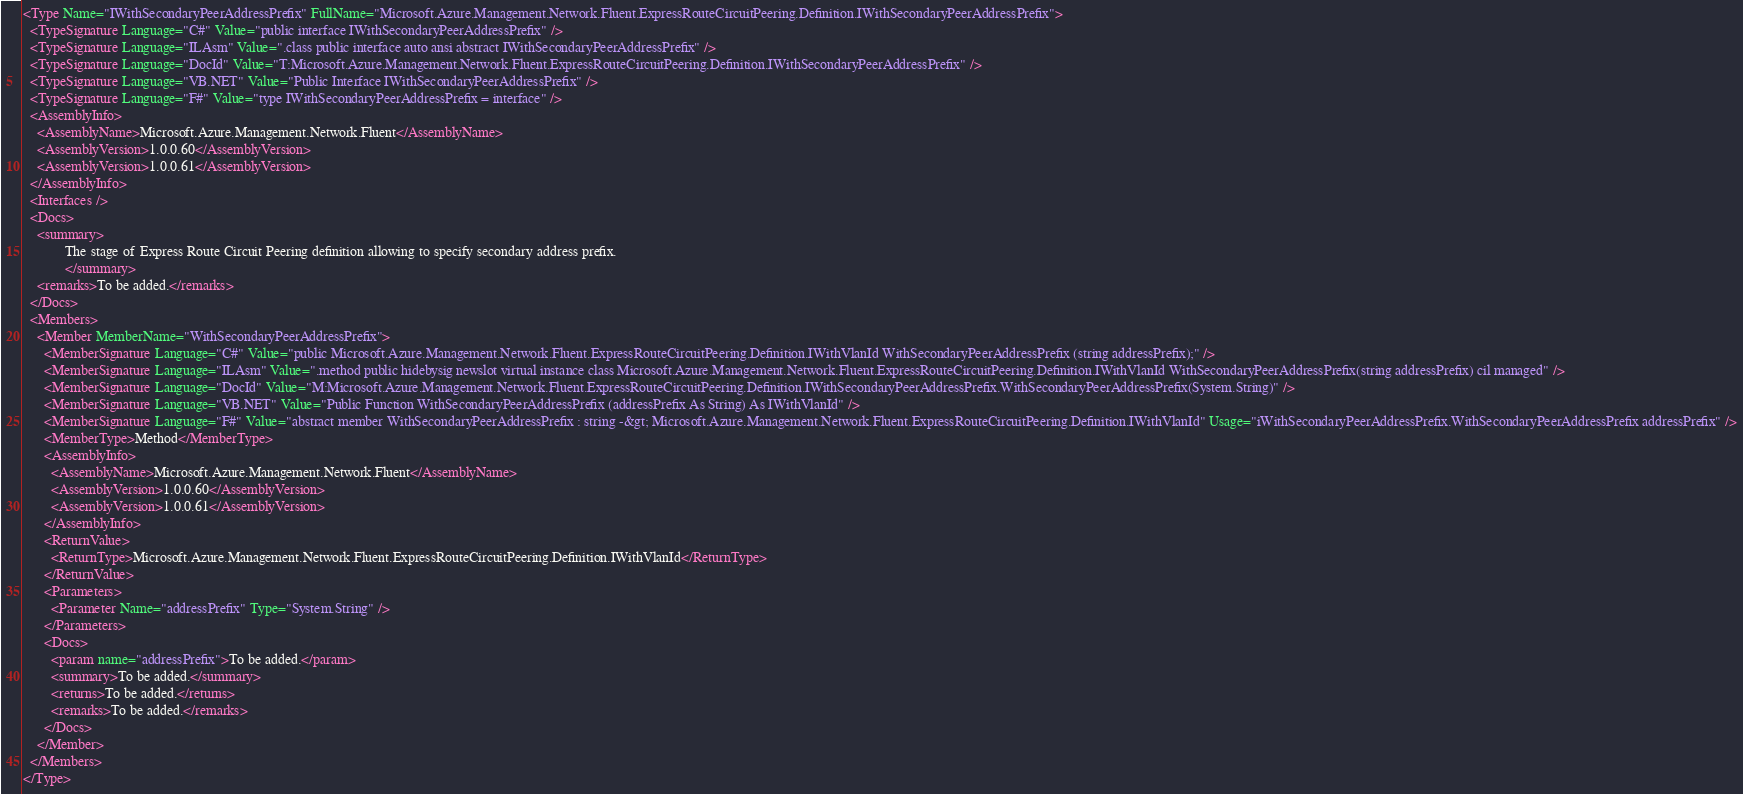<code> <loc_0><loc_0><loc_500><loc_500><_XML_><Type Name="IWithSecondaryPeerAddressPrefix" FullName="Microsoft.Azure.Management.Network.Fluent.ExpressRouteCircuitPeering.Definition.IWithSecondaryPeerAddressPrefix">
  <TypeSignature Language="C#" Value="public interface IWithSecondaryPeerAddressPrefix" />
  <TypeSignature Language="ILAsm" Value=".class public interface auto ansi abstract IWithSecondaryPeerAddressPrefix" />
  <TypeSignature Language="DocId" Value="T:Microsoft.Azure.Management.Network.Fluent.ExpressRouteCircuitPeering.Definition.IWithSecondaryPeerAddressPrefix" />
  <TypeSignature Language="VB.NET" Value="Public Interface IWithSecondaryPeerAddressPrefix" />
  <TypeSignature Language="F#" Value="type IWithSecondaryPeerAddressPrefix = interface" />
  <AssemblyInfo>
    <AssemblyName>Microsoft.Azure.Management.Network.Fluent</AssemblyName>
    <AssemblyVersion>1.0.0.60</AssemblyVersion>
    <AssemblyVersion>1.0.0.61</AssemblyVersion>
  </AssemblyInfo>
  <Interfaces />
  <Docs>
    <summary>
            The stage of Express Route Circuit Peering definition allowing to specify secondary address prefix.
            </summary>
    <remarks>To be added.</remarks>
  </Docs>
  <Members>
    <Member MemberName="WithSecondaryPeerAddressPrefix">
      <MemberSignature Language="C#" Value="public Microsoft.Azure.Management.Network.Fluent.ExpressRouteCircuitPeering.Definition.IWithVlanId WithSecondaryPeerAddressPrefix (string addressPrefix);" />
      <MemberSignature Language="ILAsm" Value=".method public hidebysig newslot virtual instance class Microsoft.Azure.Management.Network.Fluent.ExpressRouteCircuitPeering.Definition.IWithVlanId WithSecondaryPeerAddressPrefix(string addressPrefix) cil managed" />
      <MemberSignature Language="DocId" Value="M:Microsoft.Azure.Management.Network.Fluent.ExpressRouteCircuitPeering.Definition.IWithSecondaryPeerAddressPrefix.WithSecondaryPeerAddressPrefix(System.String)" />
      <MemberSignature Language="VB.NET" Value="Public Function WithSecondaryPeerAddressPrefix (addressPrefix As String) As IWithVlanId" />
      <MemberSignature Language="F#" Value="abstract member WithSecondaryPeerAddressPrefix : string -&gt; Microsoft.Azure.Management.Network.Fluent.ExpressRouteCircuitPeering.Definition.IWithVlanId" Usage="iWithSecondaryPeerAddressPrefix.WithSecondaryPeerAddressPrefix addressPrefix" />
      <MemberType>Method</MemberType>
      <AssemblyInfo>
        <AssemblyName>Microsoft.Azure.Management.Network.Fluent</AssemblyName>
        <AssemblyVersion>1.0.0.60</AssemblyVersion>
        <AssemblyVersion>1.0.0.61</AssemblyVersion>
      </AssemblyInfo>
      <ReturnValue>
        <ReturnType>Microsoft.Azure.Management.Network.Fluent.ExpressRouteCircuitPeering.Definition.IWithVlanId</ReturnType>
      </ReturnValue>
      <Parameters>
        <Parameter Name="addressPrefix" Type="System.String" />
      </Parameters>
      <Docs>
        <param name="addressPrefix">To be added.</param>
        <summary>To be added.</summary>
        <returns>To be added.</returns>
        <remarks>To be added.</remarks>
      </Docs>
    </Member>
  </Members>
</Type>
</code> 